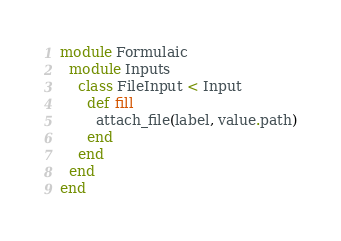Convert code to text. <code><loc_0><loc_0><loc_500><loc_500><_Ruby_>module Formulaic
  module Inputs
    class FileInput < Input
      def fill
        attach_file(label, value.path)
      end
    end
  end
end
</code> 